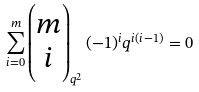Convert formula to latex. <formula><loc_0><loc_0><loc_500><loc_500>\sum _ { i = 0 } ^ { m } \begin{pmatrix} m \\ i \end{pmatrix} _ { q ^ { 2 } } ( - 1 ) ^ { i } q ^ { i ( i - 1 ) } = 0</formula> 